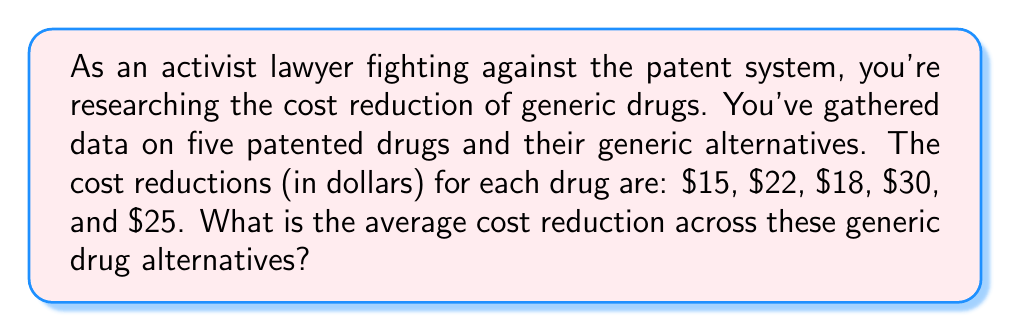Give your solution to this math problem. To solve this problem, we need to calculate the arithmetic mean of the given cost reductions. The arithmetic mean is found by summing all the values and dividing by the number of values.

Let's approach this step-by-step:

1. List the cost reductions:
   $15, $22, $18, $30, $25

2. Count the number of values:
   There are 5 cost reduction values.

3. Calculate the sum of all cost reductions:
   $15 + $22 + $18 + $30 + $25 = $110

4. Divide the sum by the number of values:
   $$\text{Average} = \frac{\text{Sum of values}}{\text{Number of values}} = \frac{110}{5} = 22$$

Therefore, the average cost reduction is $22.
Answer: $22 